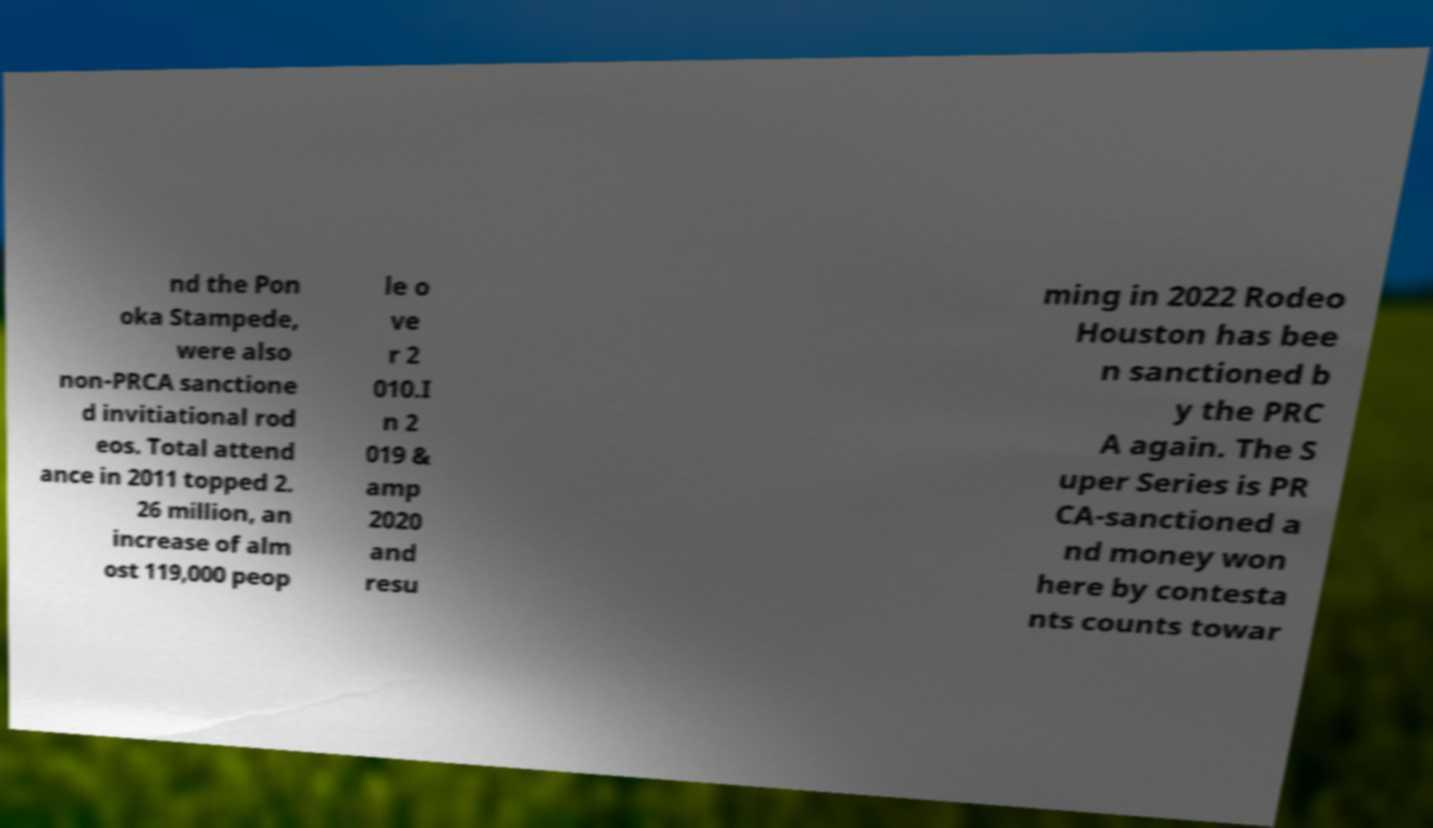Could you extract and type out the text from this image? nd the Pon oka Stampede, were also non-PRCA sanctione d invitiational rod eos. Total attend ance in 2011 topped 2. 26 million, an increase of alm ost 119,000 peop le o ve r 2 010.I n 2 019 & amp 2020 and resu ming in 2022 Rodeo Houston has bee n sanctioned b y the PRC A again. The S uper Series is PR CA-sanctioned a nd money won here by contesta nts counts towar 